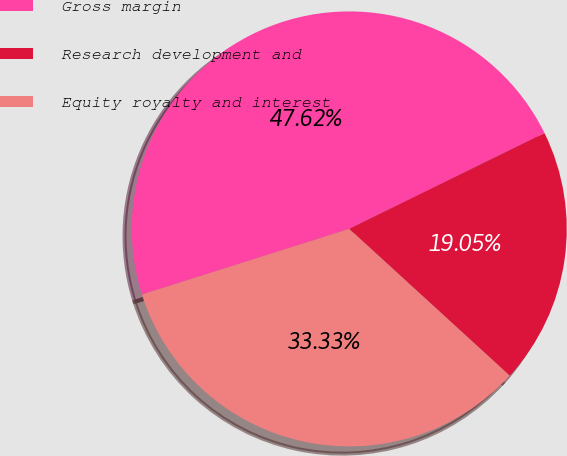Convert chart to OTSL. <chart><loc_0><loc_0><loc_500><loc_500><pie_chart><fcel>Gross margin<fcel>Research development and<fcel>Equity royalty and interest<nl><fcel>47.62%<fcel>19.05%<fcel>33.33%<nl></chart> 